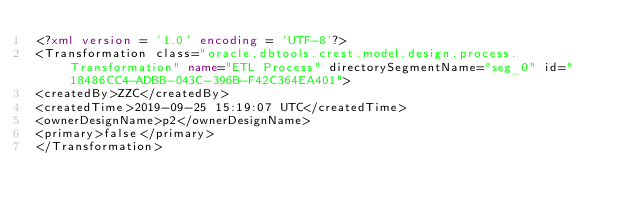Convert code to text. <code><loc_0><loc_0><loc_500><loc_500><_XML_><?xml version = '1.0' encoding = 'UTF-8'?>
<Transformation class="oracle.dbtools.crest.model.design.process.Transformation" name="ETL Process" directorySegmentName="seg_0" id="18486CC4-ADBB-043C-396B-F42C364EA401">
<createdBy>ZZC</createdBy>
<createdTime>2019-09-25 15:19:07 UTC</createdTime>
<ownerDesignName>p2</ownerDesignName>
<primary>false</primary>
</Transformation></code> 